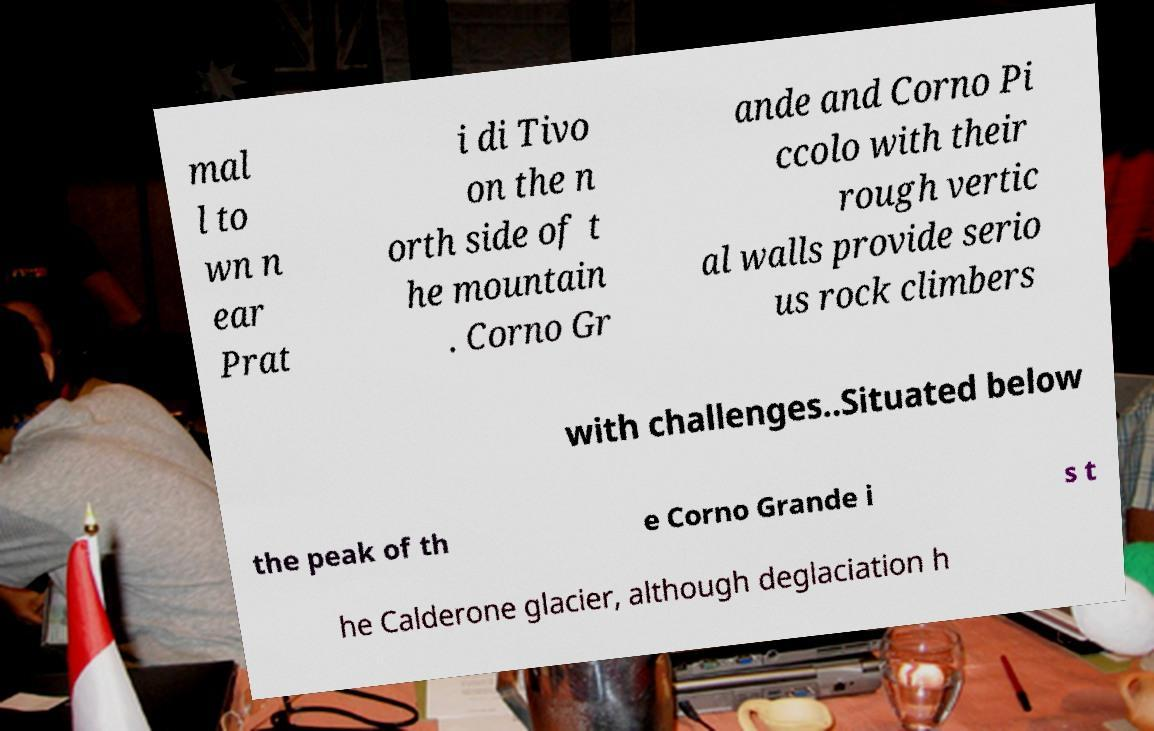Please read and relay the text visible in this image. What does it say? mal l to wn n ear Prat i di Tivo on the n orth side of t he mountain . Corno Gr ande and Corno Pi ccolo with their rough vertic al walls provide serio us rock climbers with challenges..Situated below the peak of th e Corno Grande i s t he Calderone glacier, although deglaciation h 